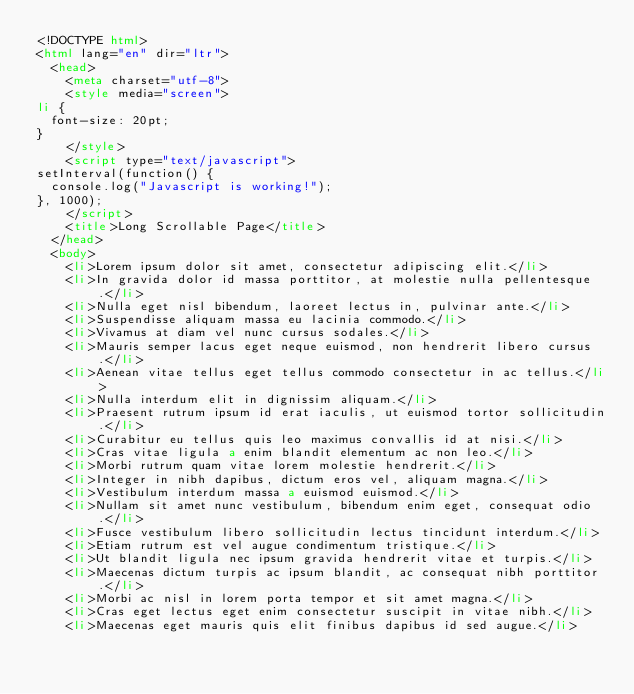<code> <loc_0><loc_0><loc_500><loc_500><_HTML_><!DOCTYPE html>
<html lang="en" dir="ltr">
  <head>
    <meta charset="utf-8">
    <style media="screen">
li {
  font-size: 20pt;
}
    </style>
    <script type="text/javascript">
setInterval(function() {
  console.log("Javascript is working!");
}, 1000);
    </script>
    <title>Long Scrollable Page</title>
  </head>
  <body>
    <li>Lorem ipsum dolor sit amet, consectetur adipiscing elit.</li>
    <li>In gravida dolor id massa porttitor, at molestie nulla pellentesque.</li>
    <li>Nulla eget nisl bibendum, laoreet lectus in, pulvinar ante.</li>
    <li>Suspendisse aliquam massa eu lacinia commodo.</li>
    <li>Vivamus at diam vel nunc cursus sodales.</li>
    <li>Mauris semper lacus eget neque euismod, non hendrerit libero cursus.</li>
    <li>Aenean vitae tellus eget tellus commodo consectetur in ac tellus.</li>
    <li>Nulla interdum elit in dignissim aliquam.</li>
    <li>Praesent rutrum ipsum id erat iaculis, ut euismod tortor sollicitudin.</li>
    <li>Curabitur eu tellus quis leo maximus convallis id at nisi.</li>
    <li>Cras vitae ligula a enim blandit elementum ac non leo.</li>
    <li>Morbi rutrum quam vitae lorem molestie hendrerit.</li>
    <li>Integer in nibh dapibus, dictum eros vel, aliquam magna.</li>
    <li>Vestibulum interdum massa a euismod euismod.</li>
    <li>Nullam sit amet nunc vestibulum, bibendum enim eget, consequat odio.</li>
    <li>Fusce vestibulum libero sollicitudin lectus tincidunt interdum.</li>
    <li>Etiam rutrum est vel augue condimentum tristique.</li>
    <li>Ut blandit ligula nec ipsum gravida hendrerit vitae et turpis.</li>
    <li>Maecenas dictum turpis ac ipsum blandit, ac consequat nibh porttitor.</li>
    <li>Morbi ac nisl in lorem porta tempor et sit amet magna.</li>
    <li>Cras eget lectus eget enim consectetur suscipit in vitae nibh.</li>
    <li>Maecenas eget mauris quis elit finibus dapibus id sed augue.</li></code> 